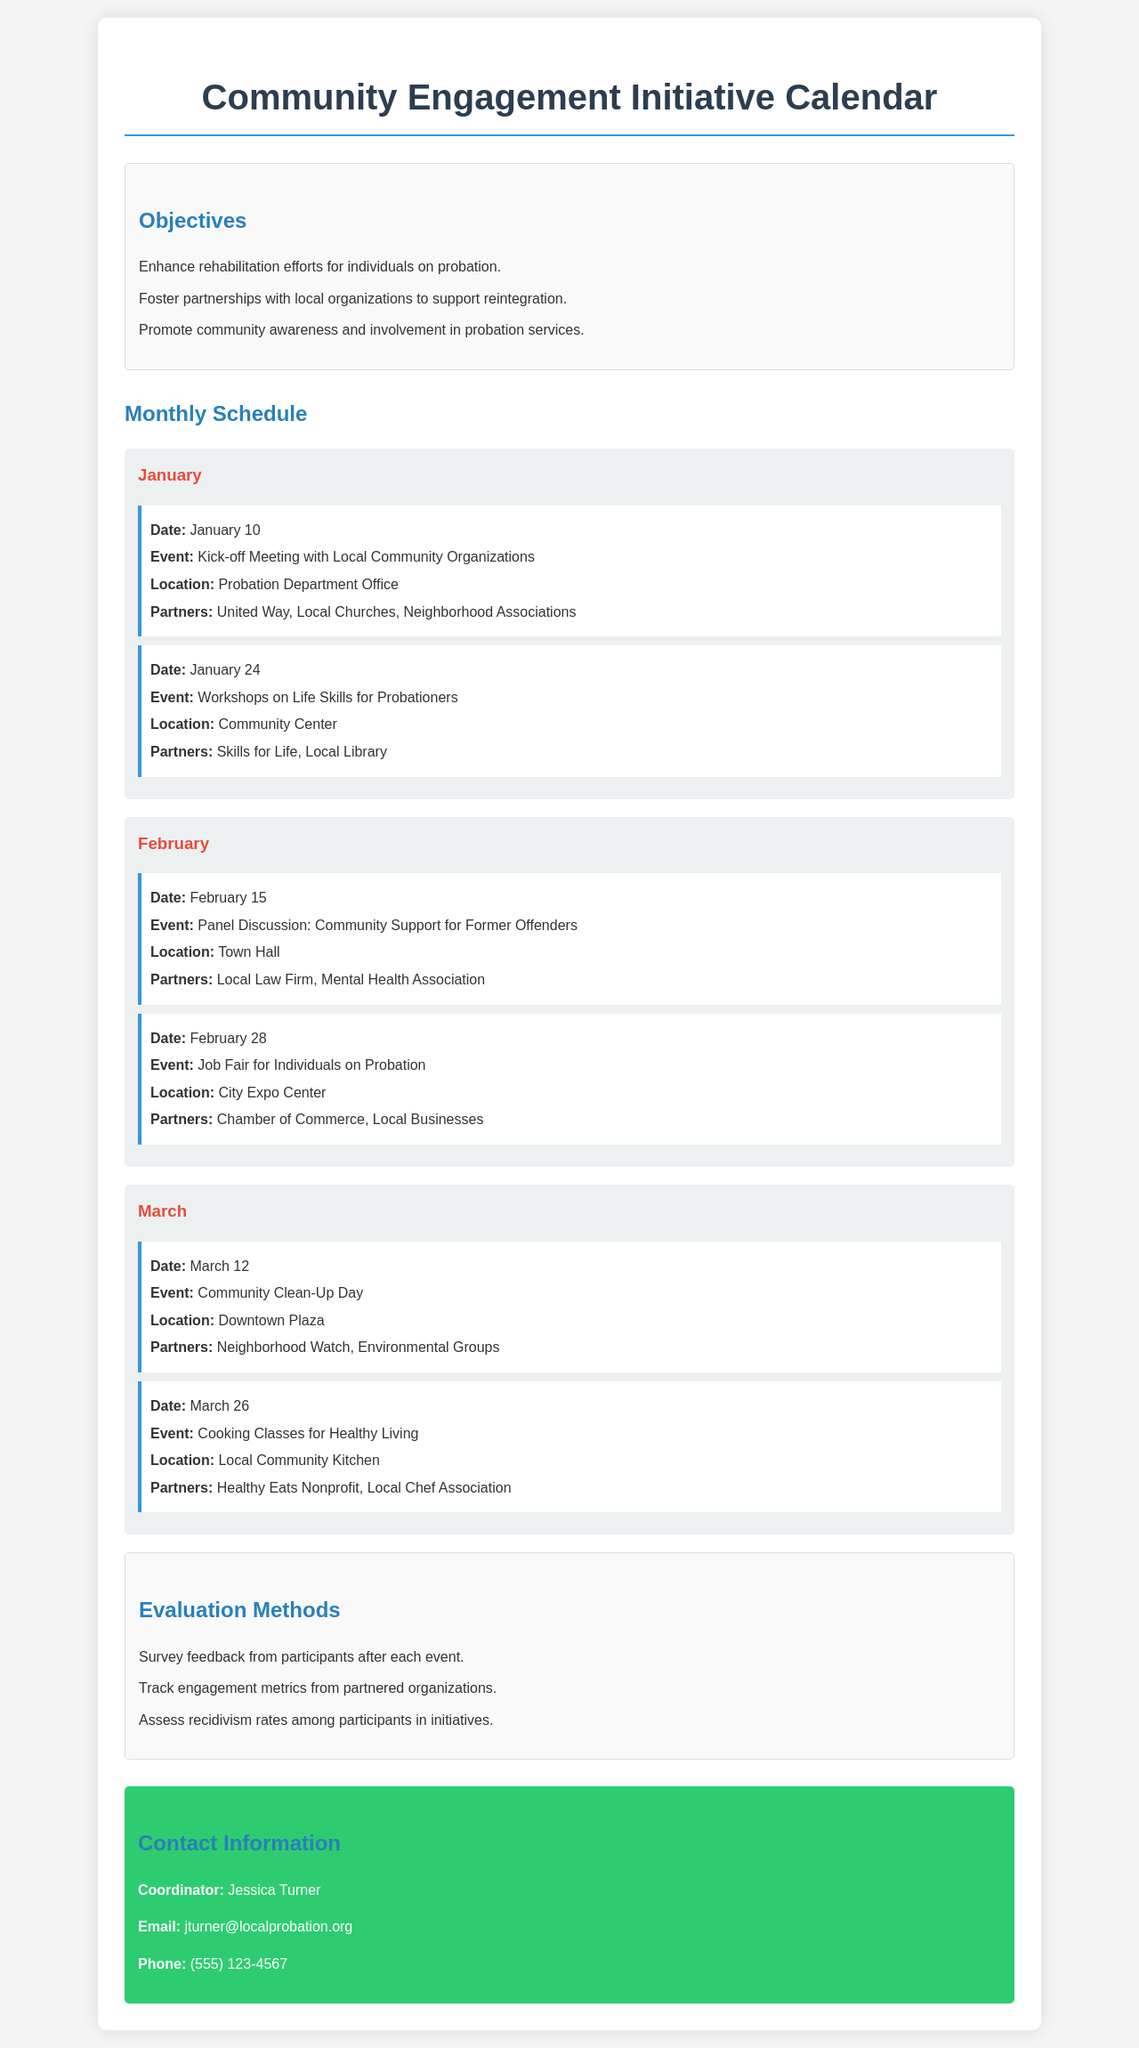what is the date of the Kick-off Meeting? The Kick-off Meeting is scheduled for January 10, as mentioned in the event details.
Answer: January 10 who are the partners for the Job Fair event? The partners for the Job Fair are listed as the Chamber of Commerce and Local Businesses.
Answer: Chamber of Commerce, Local Businesses what is the location for the Cooking Classes for Healthy Living? The location for the Cooking Classes is specified as the Local Community Kitchen in the document.
Answer: Local Community Kitchen what are the objectives of the Community Engagement Initiative? The document lists three objectives, which enhance rehabilitation efforts, foster partnerships, and promote community awareness.
Answer: Enhance rehabilitation efforts, Foster partnerships, Promote community awareness how many events are scheduled in February? There are two events scheduled in February, as indicated by the events listed for that month.
Answer: 2 which local organization is involved in the Community Clean-Up Day? The Neighborhood Watch is mentioned as a partner for the Community Clean-Up Day event according to the document.
Answer: Neighborhood Watch what method is used to evaluate the events? Surveys are mentioned as one of the methods for evaluating participant feedback after each event.
Answer: Survey feedback who is the contact coordinator for this initiative? The document states that Jessica Turner is the contact coordinator for the Community Engagement Initiative.
Answer: Jessica Turner 